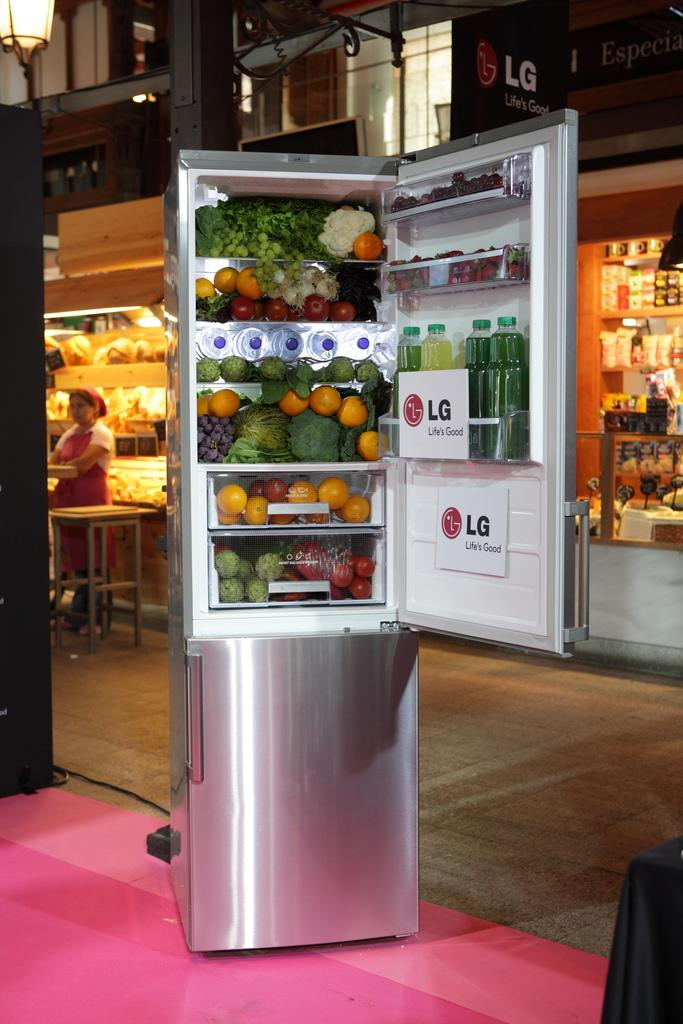Provide a one-sentence caption for the provided image. an open refrigerator with signs inside of it that say 'lg life is good'. 